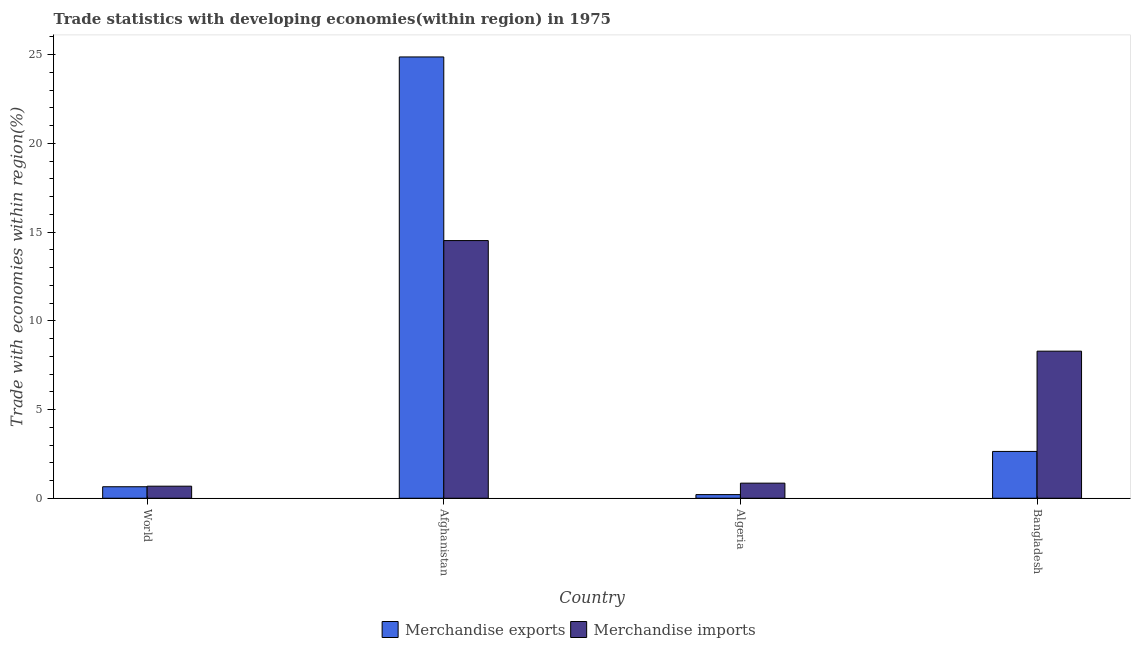How many groups of bars are there?
Provide a short and direct response. 4. Are the number of bars on each tick of the X-axis equal?
Make the answer very short. Yes. How many bars are there on the 1st tick from the left?
Give a very brief answer. 2. How many bars are there on the 1st tick from the right?
Your response must be concise. 2. In how many cases, is the number of bars for a given country not equal to the number of legend labels?
Keep it short and to the point. 0. What is the merchandise imports in Afghanistan?
Offer a very short reply. 14.52. Across all countries, what is the maximum merchandise imports?
Keep it short and to the point. 14.52. Across all countries, what is the minimum merchandise imports?
Make the answer very short. 0.68. In which country was the merchandise exports maximum?
Make the answer very short. Afghanistan. In which country was the merchandise exports minimum?
Offer a terse response. Algeria. What is the total merchandise imports in the graph?
Ensure brevity in your answer.  24.34. What is the difference between the merchandise exports in Algeria and that in Bangladesh?
Ensure brevity in your answer.  -2.43. What is the difference between the merchandise exports in Bangladesh and the merchandise imports in World?
Provide a short and direct response. 1.96. What is the average merchandise imports per country?
Offer a terse response. 6.08. What is the difference between the merchandise imports and merchandise exports in Bangladesh?
Offer a terse response. 5.65. In how many countries, is the merchandise imports greater than 25 %?
Offer a very short reply. 0. What is the ratio of the merchandise exports in Bangladesh to that in World?
Provide a succinct answer. 4.07. What is the difference between the highest and the second highest merchandise imports?
Ensure brevity in your answer.  6.23. What is the difference between the highest and the lowest merchandise exports?
Your response must be concise. 24.66. What does the 1st bar from the left in Algeria represents?
Give a very brief answer. Merchandise exports. How many bars are there?
Provide a short and direct response. 8. What is the difference between two consecutive major ticks on the Y-axis?
Ensure brevity in your answer.  5. Does the graph contain any zero values?
Keep it short and to the point. No. Does the graph contain grids?
Ensure brevity in your answer.  No. Where does the legend appear in the graph?
Your answer should be very brief. Bottom center. What is the title of the graph?
Provide a succinct answer. Trade statistics with developing economies(within region) in 1975. Does "Lowest 20% of population" appear as one of the legend labels in the graph?
Your answer should be compact. No. What is the label or title of the Y-axis?
Provide a succinct answer. Trade with economies within region(%). What is the Trade with economies within region(%) of Merchandise exports in World?
Your response must be concise. 0.65. What is the Trade with economies within region(%) in Merchandise imports in World?
Offer a very short reply. 0.68. What is the Trade with economies within region(%) of Merchandise exports in Afghanistan?
Provide a succinct answer. 24.87. What is the Trade with economies within region(%) of Merchandise imports in Afghanistan?
Offer a very short reply. 14.52. What is the Trade with economies within region(%) of Merchandise exports in Algeria?
Offer a terse response. 0.21. What is the Trade with economies within region(%) of Merchandise imports in Algeria?
Make the answer very short. 0.85. What is the Trade with economies within region(%) in Merchandise exports in Bangladesh?
Offer a terse response. 2.64. What is the Trade with economies within region(%) in Merchandise imports in Bangladesh?
Offer a very short reply. 8.29. Across all countries, what is the maximum Trade with economies within region(%) in Merchandise exports?
Your response must be concise. 24.87. Across all countries, what is the maximum Trade with economies within region(%) in Merchandise imports?
Give a very brief answer. 14.52. Across all countries, what is the minimum Trade with economies within region(%) of Merchandise exports?
Give a very brief answer. 0.21. Across all countries, what is the minimum Trade with economies within region(%) of Merchandise imports?
Give a very brief answer. 0.68. What is the total Trade with economies within region(%) in Merchandise exports in the graph?
Provide a succinct answer. 28.36. What is the total Trade with economies within region(%) in Merchandise imports in the graph?
Your response must be concise. 24.34. What is the difference between the Trade with economies within region(%) in Merchandise exports in World and that in Afghanistan?
Your answer should be very brief. -24.22. What is the difference between the Trade with economies within region(%) of Merchandise imports in World and that in Afghanistan?
Give a very brief answer. -13.84. What is the difference between the Trade with economies within region(%) of Merchandise exports in World and that in Algeria?
Your answer should be compact. 0.44. What is the difference between the Trade with economies within region(%) of Merchandise imports in World and that in Algeria?
Make the answer very short. -0.17. What is the difference between the Trade with economies within region(%) of Merchandise exports in World and that in Bangladesh?
Your answer should be very brief. -1.99. What is the difference between the Trade with economies within region(%) in Merchandise imports in World and that in Bangladesh?
Offer a terse response. -7.61. What is the difference between the Trade with economies within region(%) in Merchandise exports in Afghanistan and that in Algeria?
Your answer should be compact. 24.66. What is the difference between the Trade with economies within region(%) of Merchandise imports in Afghanistan and that in Algeria?
Your response must be concise. 13.67. What is the difference between the Trade with economies within region(%) of Merchandise exports in Afghanistan and that in Bangladesh?
Your answer should be compact. 22.23. What is the difference between the Trade with economies within region(%) in Merchandise imports in Afghanistan and that in Bangladesh?
Ensure brevity in your answer.  6.23. What is the difference between the Trade with economies within region(%) in Merchandise exports in Algeria and that in Bangladesh?
Your answer should be compact. -2.43. What is the difference between the Trade with economies within region(%) of Merchandise imports in Algeria and that in Bangladesh?
Give a very brief answer. -7.44. What is the difference between the Trade with economies within region(%) in Merchandise exports in World and the Trade with economies within region(%) in Merchandise imports in Afghanistan?
Provide a succinct answer. -13.87. What is the difference between the Trade with economies within region(%) in Merchandise exports in World and the Trade with economies within region(%) in Merchandise imports in Algeria?
Your response must be concise. -0.2. What is the difference between the Trade with economies within region(%) of Merchandise exports in World and the Trade with economies within region(%) of Merchandise imports in Bangladesh?
Offer a very short reply. -7.64. What is the difference between the Trade with economies within region(%) in Merchandise exports in Afghanistan and the Trade with economies within region(%) in Merchandise imports in Algeria?
Your response must be concise. 24.02. What is the difference between the Trade with economies within region(%) in Merchandise exports in Afghanistan and the Trade with economies within region(%) in Merchandise imports in Bangladesh?
Ensure brevity in your answer.  16.58. What is the difference between the Trade with economies within region(%) in Merchandise exports in Algeria and the Trade with economies within region(%) in Merchandise imports in Bangladesh?
Give a very brief answer. -8.08. What is the average Trade with economies within region(%) in Merchandise exports per country?
Your response must be concise. 7.09. What is the average Trade with economies within region(%) of Merchandise imports per country?
Your response must be concise. 6.08. What is the difference between the Trade with economies within region(%) in Merchandise exports and Trade with economies within region(%) in Merchandise imports in World?
Make the answer very short. -0.03. What is the difference between the Trade with economies within region(%) in Merchandise exports and Trade with economies within region(%) in Merchandise imports in Afghanistan?
Ensure brevity in your answer.  10.35. What is the difference between the Trade with economies within region(%) in Merchandise exports and Trade with economies within region(%) in Merchandise imports in Algeria?
Your answer should be compact. -0.65. What is the difference between the Trade with economies within region(%) in Merchandise exports and Trade with economies within region(%) in Merchandise imports in Bangladesh?
Make the answer very short. -5.65. What is the ratio of the Trade with economies within region(%) in Merchandise exports in World to that in Afghanistan?
Keep it short and to the point. 0.03. What is the ratio of the Trade with economies within region(%) of Merchandise imports in World to that in Afghanistan?
Your response must be concise. 0.05. What is the ratio of the Trade with economies within region(%) in Merchandise exports in World to that in Algeria?
Ensure brevity in your answer.  3.16. What is the ratio of the Trade with economies within region(%) of Merchandise imports in World to that in Algeria?
Provide a short and direct response. 0.8. What is the ratio of the Trade with economies within region(%) of Merchandise exports in World to that in Bangladesh?
Ensure brevity in your answer.  0.25. What is the ratio of the Trade with economies within region(%) of Merchandise imports in World to that in Bangladesh?
Ensure brevity in your answer.  0.08. What is the ratio of the Trade with economies within region(%) in Merchandise exports in Afghanistan to that in Algeria?
Your response must be concise. 121.1. What is the ratio of the Trade with economies within region(%) of Merchandise imports in Afghanistan to that in Algeria?
Offer a terse response. 17.07. What is the ratio of the Trade with economies within region(%) of Merchandise exports in Afghanistan to that in Bangladesh?
Keep it short and to the point. 9.43. What is the ratio of the Trade with economies within region(%) in Merchandise imports in Afghanistan to that in Bangladesh?
Offer a terse response. 1.75. What is the ratio of the Trade with economies within region(%) of Merchandise exports in Algeria to that in Bangladesh?
Give a very brief answer. 0.08. What is the ratio of the Trade with economies within region(%) in Merchandise imports in Algeria to that in Bangladesh?
Make the answer very short. 0.1. What is the difference between the highest and the second highest Trade with economies within region(%) in Merchandise exports?
Keep it short and to the point. 22.23. What is the difference between the highest and the second highest Trade with economies within region(%) in Merchandise imports?
Ensure brevity in your answer.  6.23. What is the difference between the highest and the lowest Trade with economies within region(%) of Merchandise exports?
Ensure brevity in your answer.  24.66. What is the difference between the highest and the lowest Trade with economies within region(%) of Merchandise imports?
Keep it short and to the point. 13.84. 